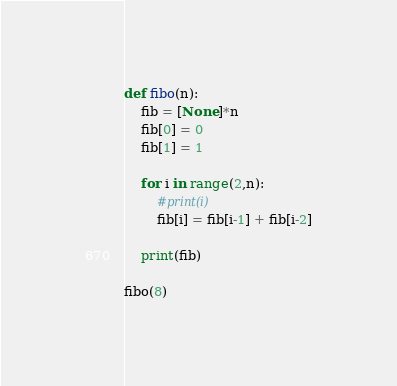Convert code to text. <code><loc_0><loc_0><loc_500><loc_500><_Python_>def fibo(n):
    fib = [None]*n
    fib[0] = 0
    fib[1] = 1

    for i in range(2,n):
        #print(i)
        fib[i] = fib[i-1] + fib[i-2]

    print(fib)

fibo(8)
</code> 